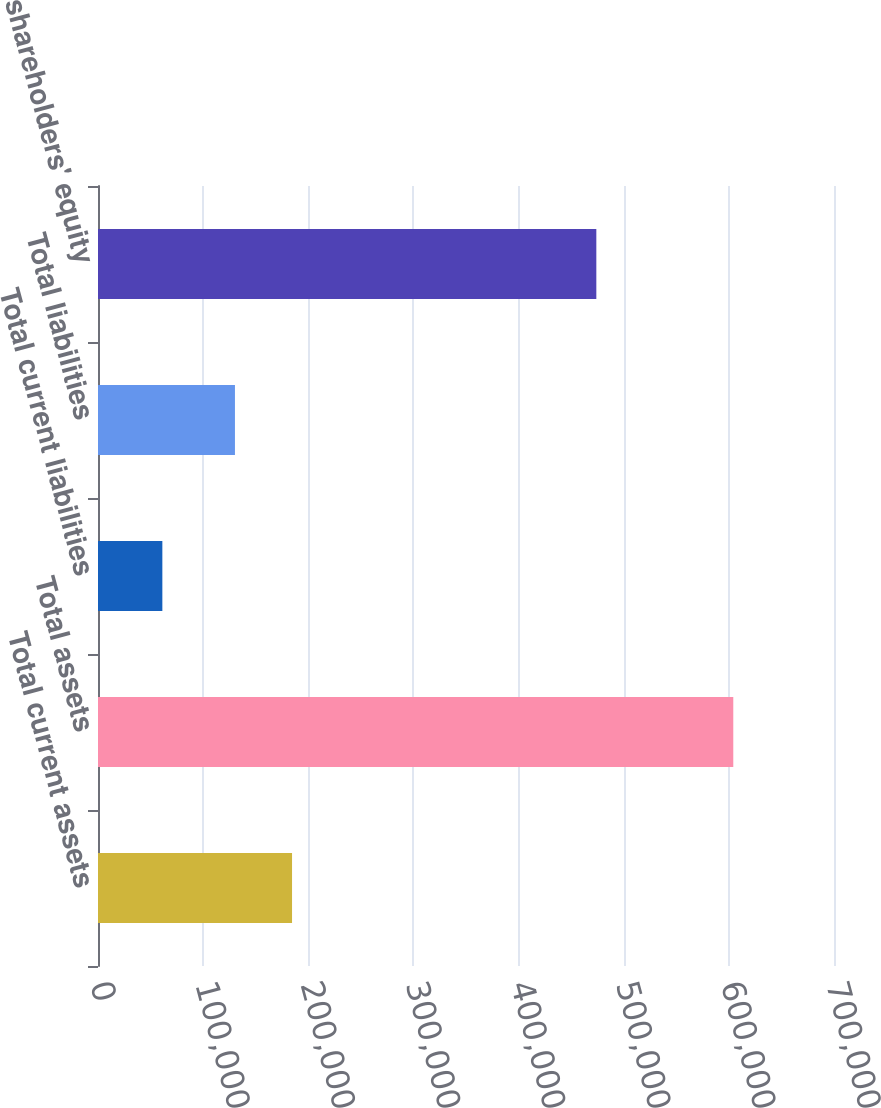<chart> <loc_0><loc_0><loc_500><loc_500><bar_chart><fcel>Total current assets<fcel>Total assets<fcel>Total current liabilities<fcel>Total liabilities<fcel>Total shareholders' equity<nl><fcel>184552<fcel>604208<fcel>61201<fcel>130251<fcel>473957<nl></chart> 